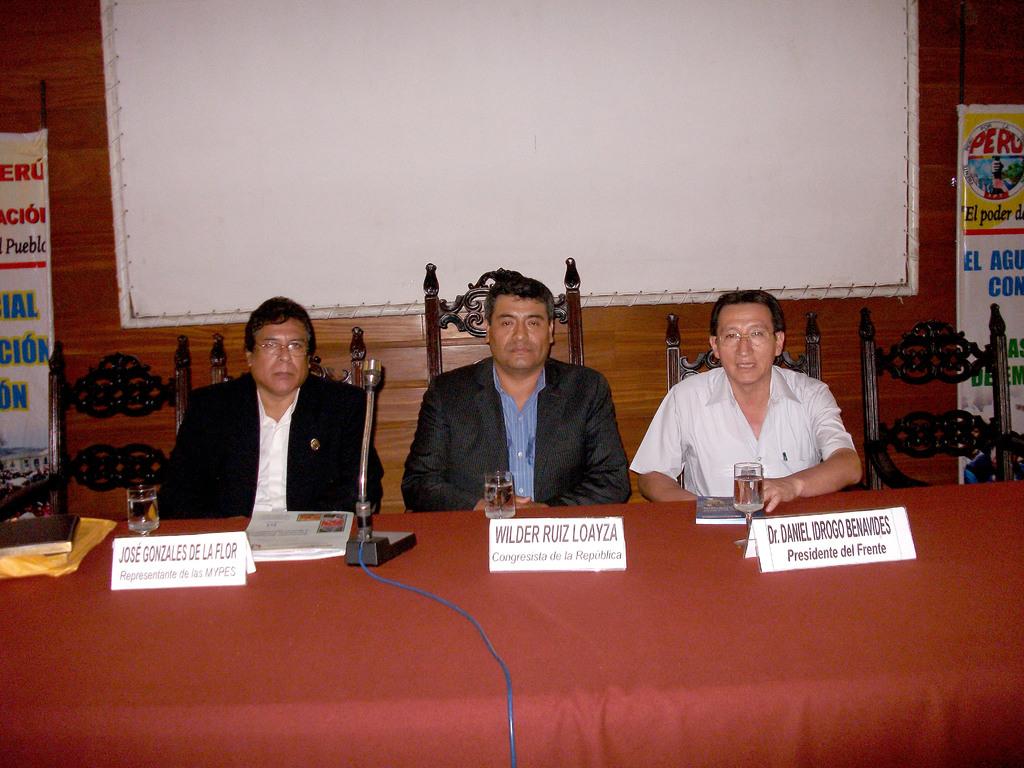What is the man in the middle?
Your answer should be compact. Wilder ruiz loayza. Where is dr. daniel sitting?
Give a very brief answer. On the right. 